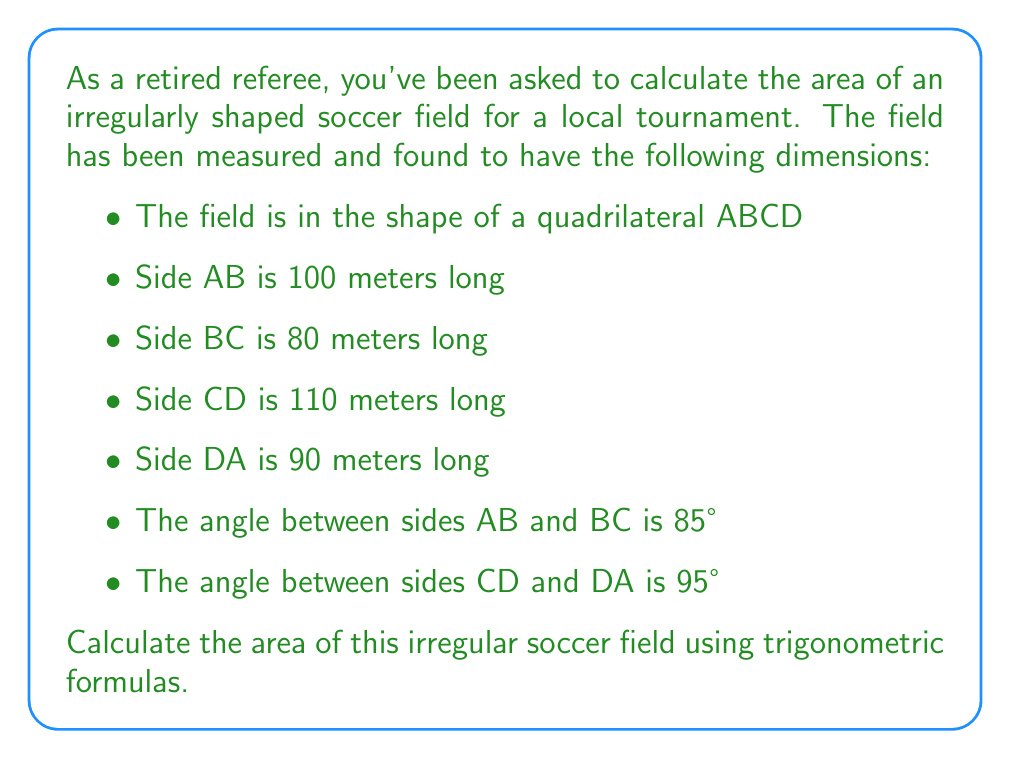What is the answer to this math problem? To calculate the area of this irregular quadrilateral, we can use the following approach:

1. Divide the quadrilateral into two triangles by drawing a diagonal.
2. Calculate the area of each triangle using the trigonometric area formula.
3. Sum the areas of the two triangles.

Let's choose the diagonal AC to divide the quadrilateral.

For triangle ABC:
- We know two sides (AB = 100m, BC = 80m) and the included angle (85°).
- Area of triangle ABC = $\frac{1}{2} \cdot AB \cdot BC \cdot \sin(85°)$
- $Area_{ABC} = \frac{1}{2} \cdot 100 \cdot 80 \cdot \sin(85°) = 3984.87 \text{ m}^2$

For triangle ACD:
- We know two sides (CD = 110m, DA = 90m) and the included angle (95°).
- Area of triangle ACD = $\frac{1}{2} \cdot CD \cdot DA \cdot \sin(95°)$
- $Area_{ACD} = \frac{1}{2} \cdot 110 \cdot 90 \cdot \sin(95°) = 4897.79 \text{ m}^2$

The total area of the quadrilateral is the sum of these two triangles:

$Area_{total} = Area_{ABC} + Area_{ACD}$
$Area_{total} = 3984.87 + 4897.79 = 8882.66 \text{ m}^2$

Therefore, the area of the irregular soccer field is approximately 8882.66 square meters.
Answer: The area of the irregular soccer field is approximately 8882.66 square meters. 